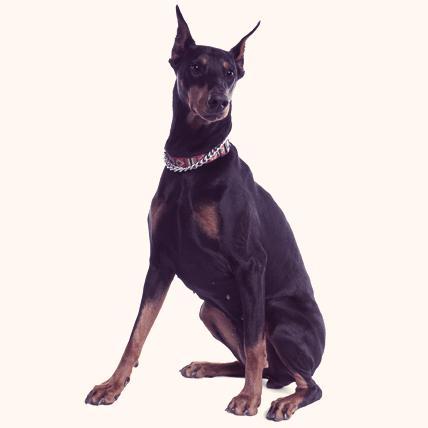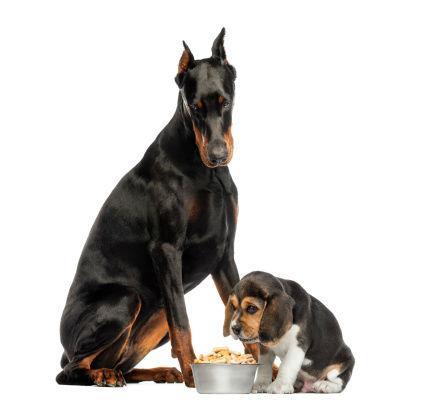The first image is the image on the left, the second image is the image on the right. Examine the images to the left and right. Is the description "More than one doberman is sitting." accurate? Answer yes or no. Yes. The first image is the image on the left, the second image is the image on the right. Evaluate the accuracy of this statement regarding the images: "The left image shows a doberman wearing a collar, and the right image shows a doberman sitting upright without a collar on.". Is it true? Answer yes or no. Yes. 